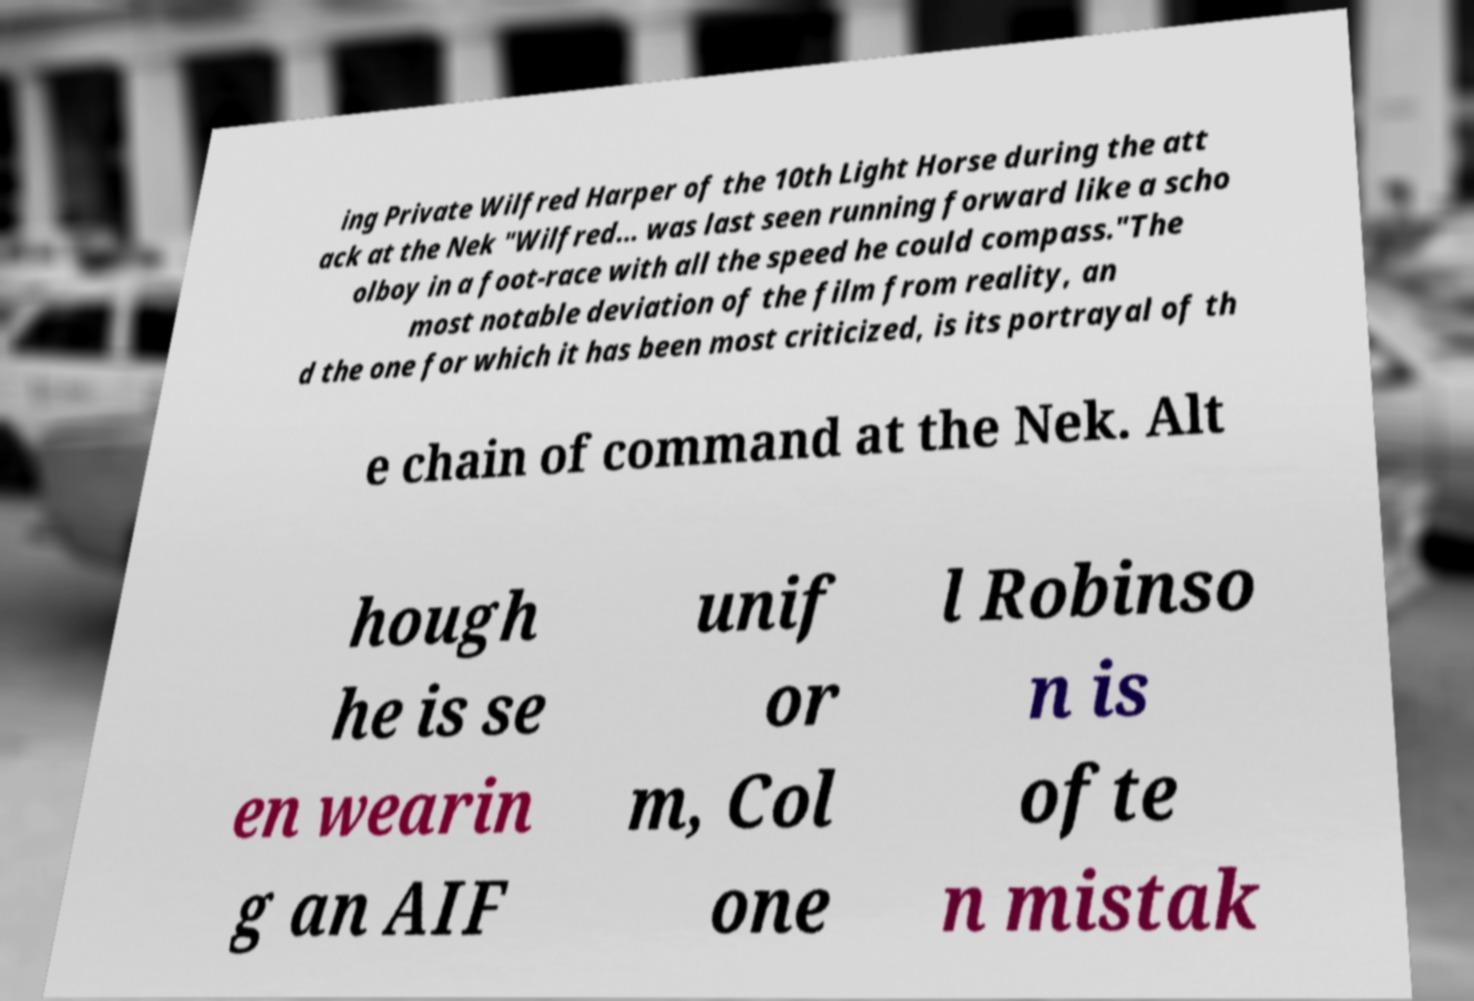I need the written content from this picture converted into text. Can you do that? ing Private Wilfred Harper of the 10th Light Horse during the att ack at the Nek "Wilfred... was last seen running forward like a scho olboy in a foot-race with all the speed he could compass."The most notable deviation of the film from reality, an d the one for which it has been most criticized, is its portrayal of th e chain of command at the Nek. Alt hough he is se en wearin g an AIF unif or m, Col one l Robinso n is ofte n mistak 